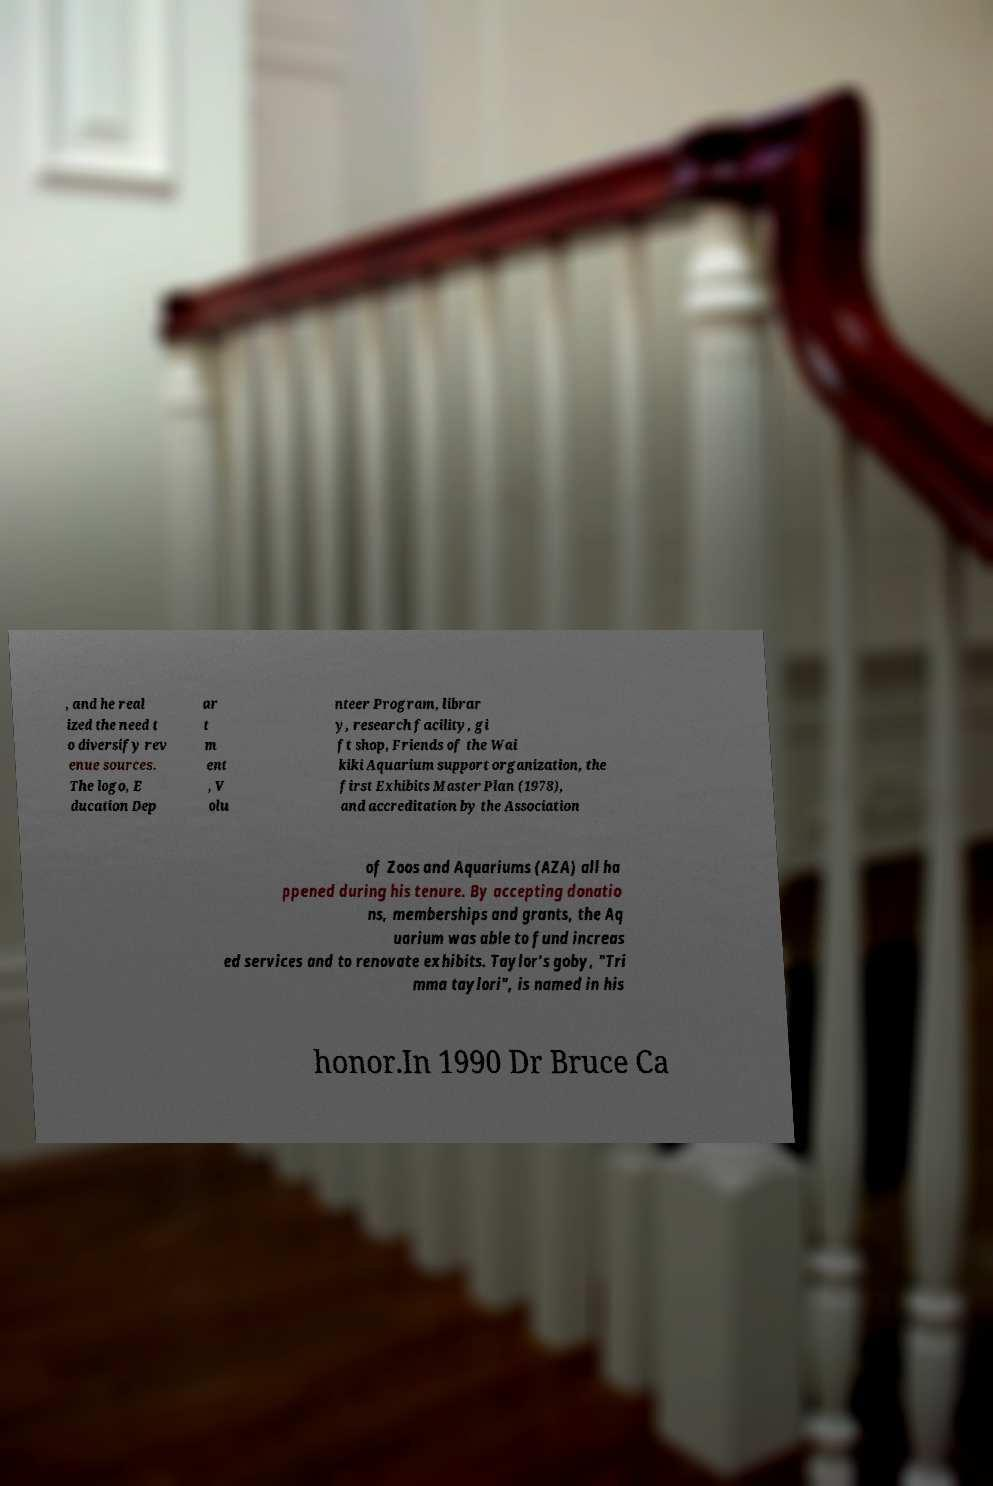For documentation purposes, I need the text within this image transcribed. Could you provide that? , and he real ized the need t o diversify rev enue sources. The logo, E ducation Dep ar t m ent , V olu nteer Program, librar y, research facility, gi ft shop, Friends of the Wai kiki Aquarium support organization, the first Exhibits Master Plan (1978), and accreditation by the Association of Zoos and Aquariums (AZA) all ha ppened during his tenure. By accepting donatio ns, memberships and grants, the Aq uarium was able to fund increas ed services and to renovate exhibits. Taylor's goby, "Tri mma taylori", is named in his honor.In 1990 Dr Bruce Ca 